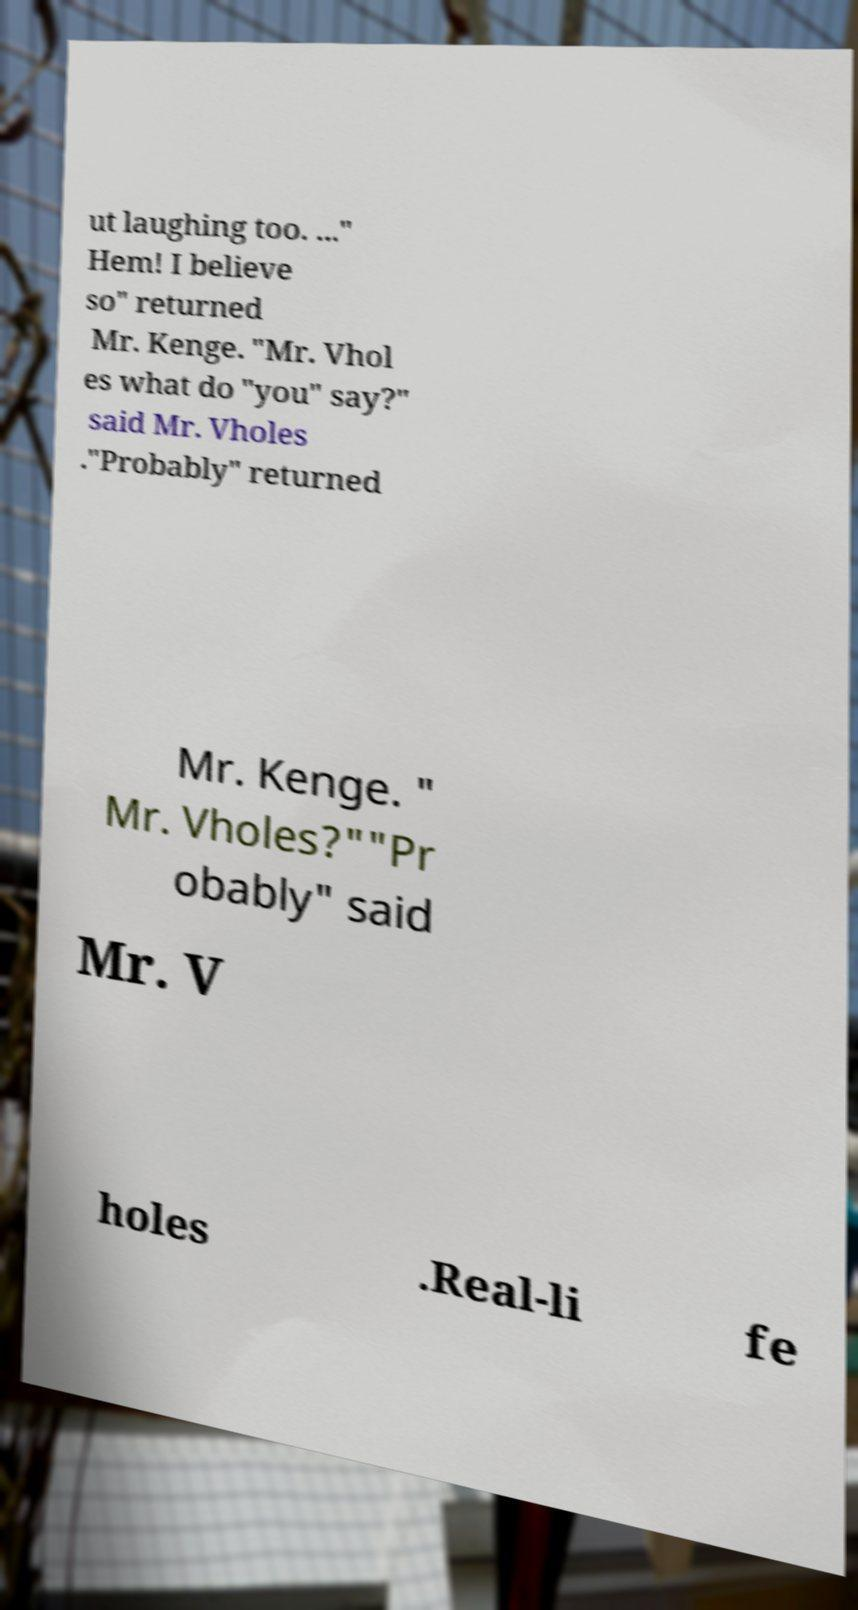What messages or text are displayed in this image? I need them in a readable, typed format. ut laughing too. ..." Hem! I believe so" returned Mr. Kenge. "Mr. Vhol es what do "you" say?" said Mr. Vholes ."Probably" returned Mr. Kenge. " Mr. Vholes?""Pr obably" said Mr. V holes .Real-li fe 